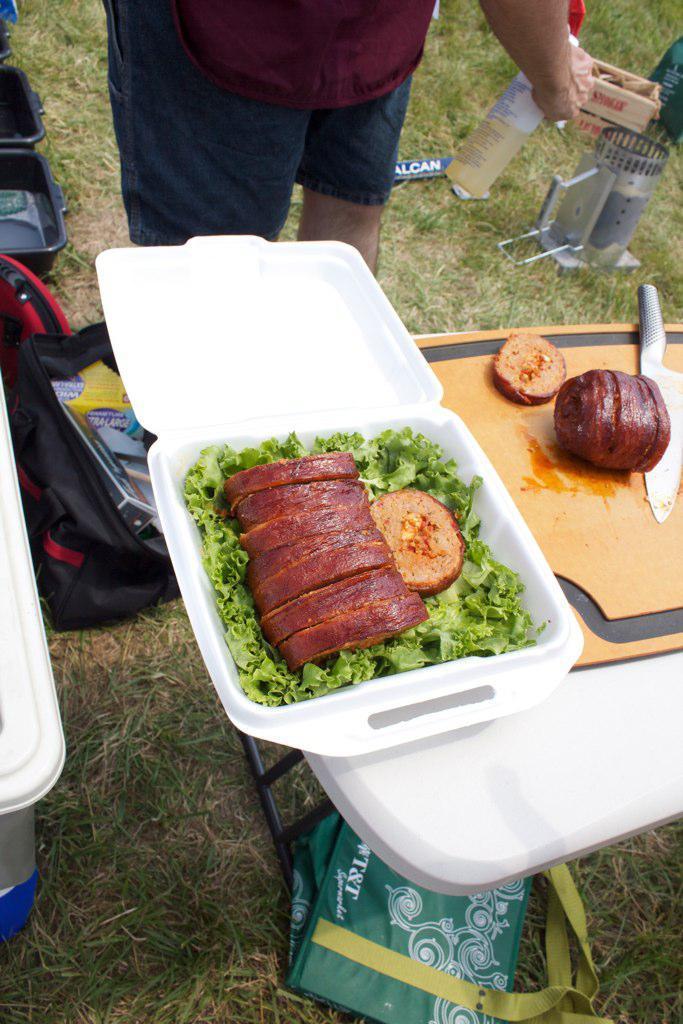Can you describe this image briefly? In this image in the front there is a table, on the table there is food in the box which is white in colour and there is a chopping board, on the chopping board there is a knife and food, under the table there is an object which is green in colour on the ground. In the background there is a person standing and there are objects which are on the ground and the person is holding a bottle in his hand and there is grass on the ground. On the left side there is a box which is white in colour. 